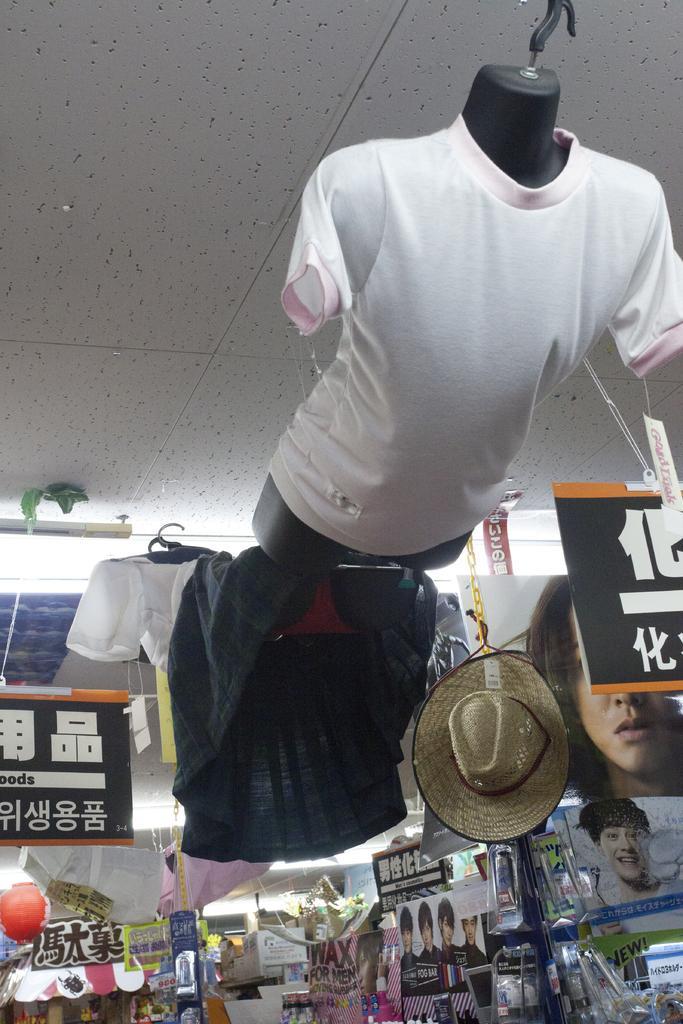How would you summarize this image in a sentence or two? In this image I can see a t shirt on a mannequin. There are clothes and a hat is hanging. There are boards and other objects in the store. 